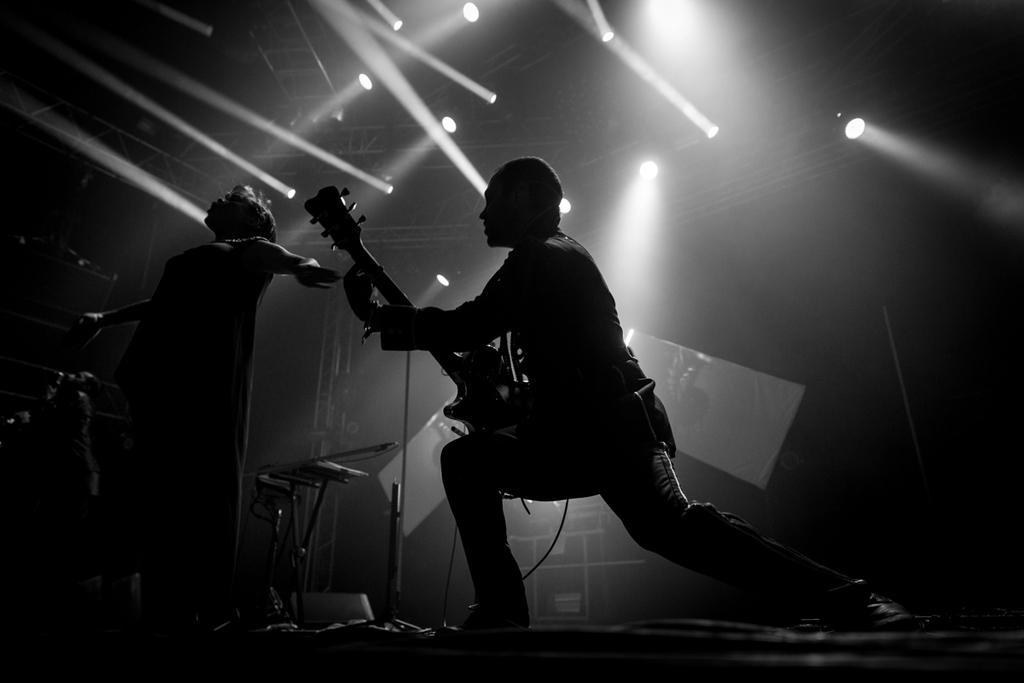How would you summarize this image in a sentence or two? This person is holding a guitar. This person is standing. These are musical instrument. On a roof there are holes. 